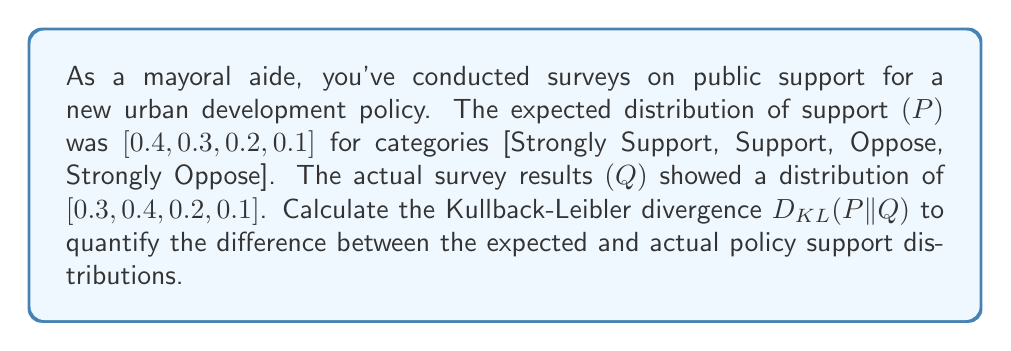Teach me how to tackle this problem. To calculate the Kullback-Leibler divergence between the expected distribution P and the actual distribution Q, we use the formula:

$$D_{KL}(P||Q) = \sum_{i} P(i) \log\left(\frac{P(i)}{Q(i)}\right)$$

Where $P(i)$ and $Q(i)$ are the probabilities of each category in the respective distributions.

Let's calculate each term:

1. For "Strongly Support":
   $P(1) = 0.4, Q(1) = 0.3$
   $0.4 \log\left(\frac{0.4}{0.3}\right) = 0.4 \log(1.333) \approx 0.0472$

2. For "Support":
   $P(2) = 0.3, Q(2) = 0.4$
   $0.3 \log\left(\frac{0.3}{0.4}\right) = 0.3 \log(0.75) \approx -0.0864$

3. For "Oppose":
   $P(3) = 0.2, Q(3) = 0.2$
   $0.2 \log\left(\frac{0.2}{0.2}\right) = 0.2 \log(1) = 0$

4. For "Strongly Oppose":
   $P(4) = 0.1, Q(4) = 0.1$
   $0.1 \log\left(\frac{0.1}{0.1}\right) = 0.1 \log(1) = 0$

Now, sum all these terms:

$$D_{KL}(P||Q) = 0.0472 + (-0.0864) + 0 + 0 = -0.0392$$

The negative result indicates that the actual distribution Q has higher entropy than the expected distribution P.
Answer: $D_{KL}(P||Q) \approx -0.0392$ 